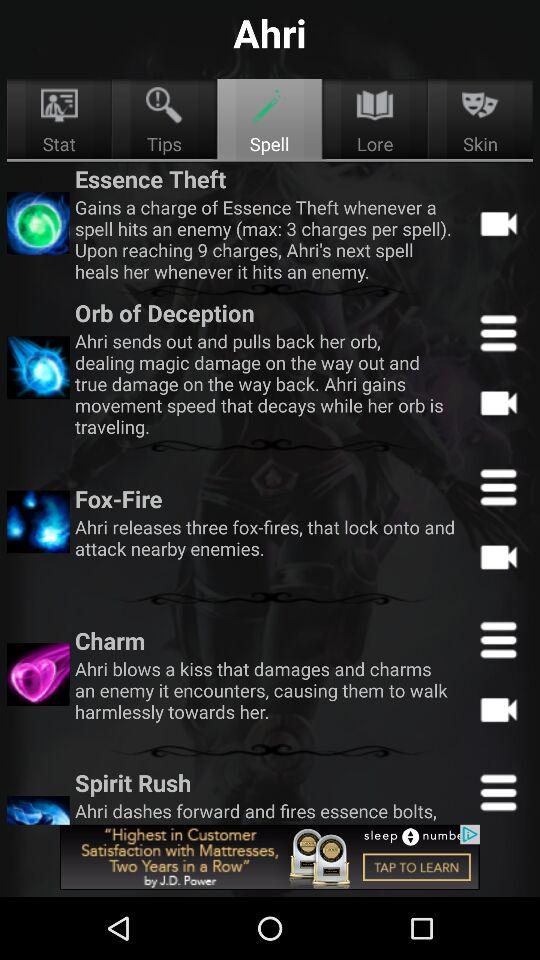What is the total number of fox-fires that have been released? The total number of fox-fires that have been released is three. 